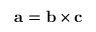Convert formula to latex. <formula><loc_0><loc_0><loc_500><loc_500>a = b \times c</formula> 